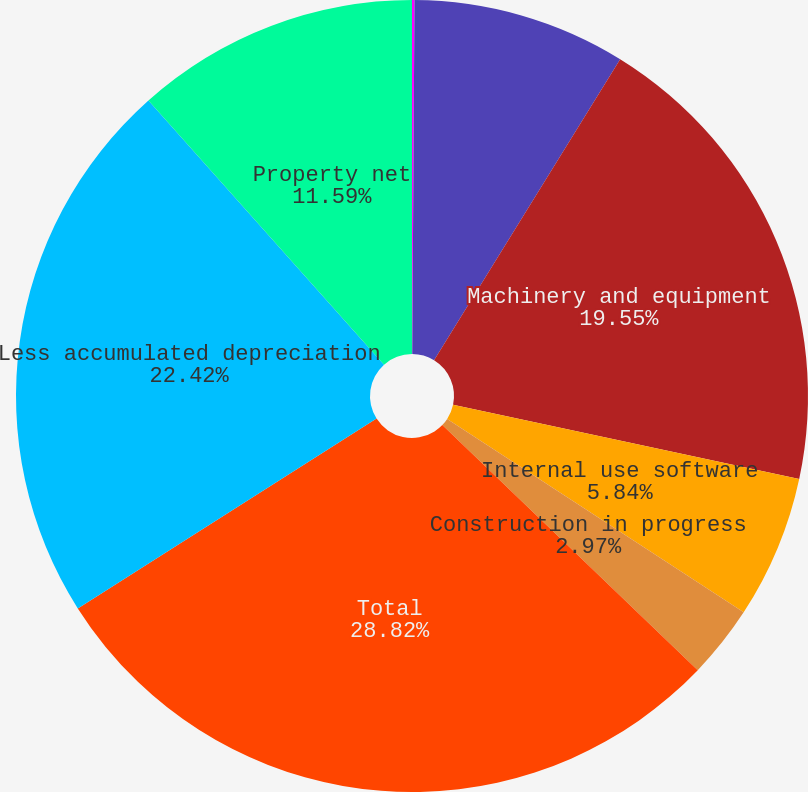<chart> <loc_0><loc_0><loc_500><loc_500><pie_chart><fcel>Land<fcel>Buildings and improvements<fcel>Machinery and equipment<fcel>Internal use software<fcel>Construction in progress<fcel>Total<fcel>Less accumulated depreciation<fcel>Property net<nl><fcel>0.1%<fcel>8.71%<fcel>19.55%<fcel>5.84%<fcel>2.97%<fcel>28.82%<fcel>22.42%<fcel>11.59%<nl></chart> 